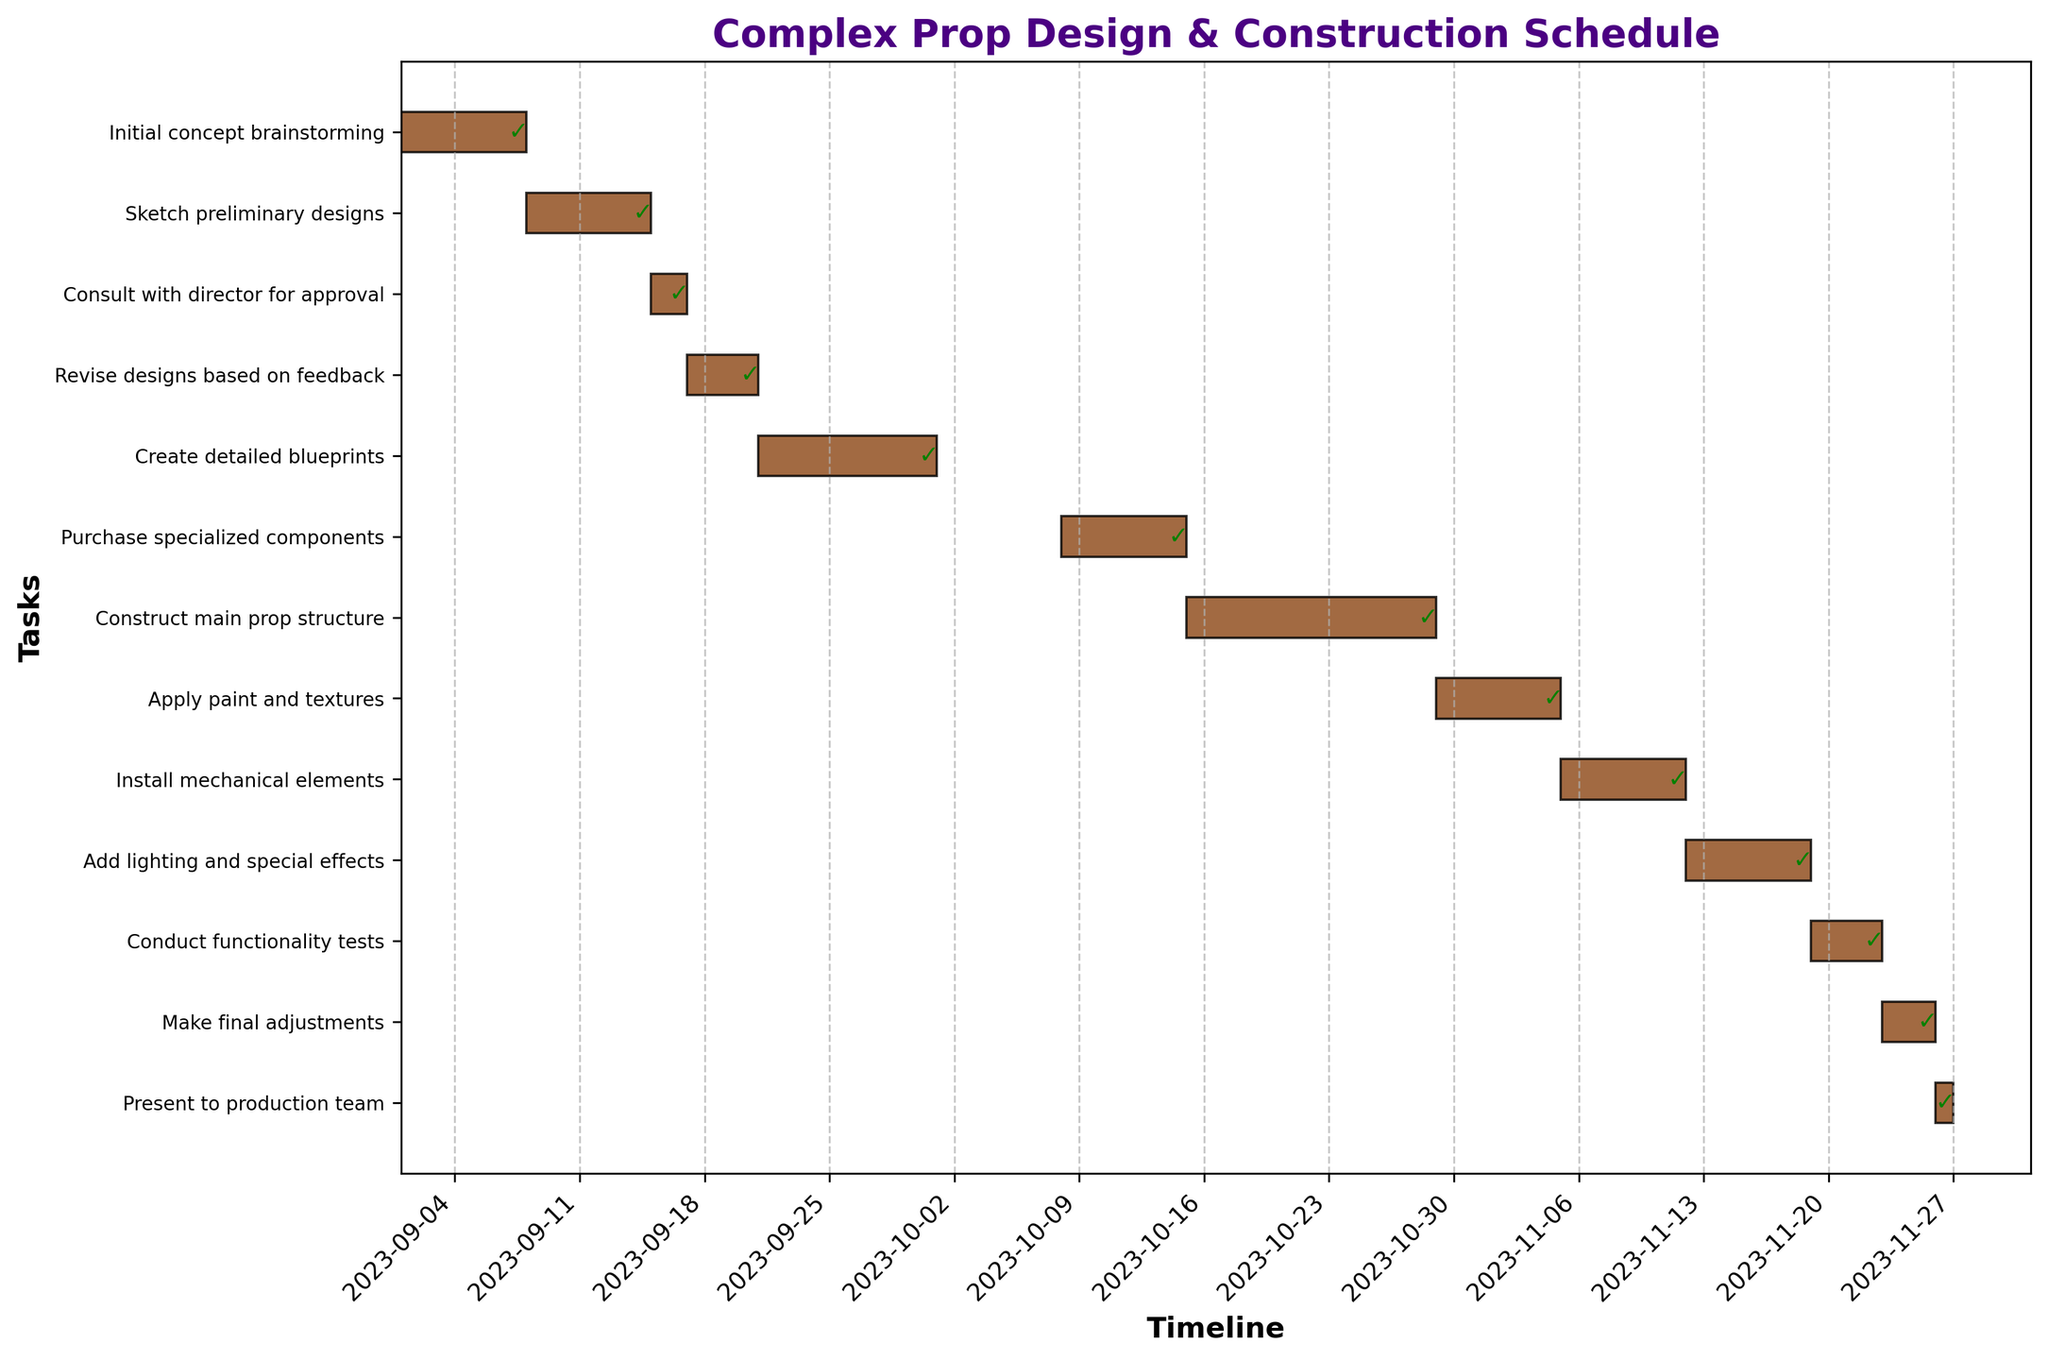What's the title of the Gantt chart? The title of the Gantt chart is located at the top-center in bold and larger font size, which typically gives an overview of the graph. In this case, it should summarize the project schedule.
Answer: Complex Prop Design & Construction Schedule How long is the duration for "Construct main prop structure" task? To find the duration, you need to look at the start and end dates for the task "Construct main prop structure" which runs from 2023-10-15 to 2023-10-28. The duration is 14 days.
Answer: 14 days Which task took the shortest time to complete? Look for the task with the shortest bar on the horizontal axis. The task "Present to production team" is completed in a single day, making it the shortest.
Answer: Present to production team What tasks are scheduled to occur in November? Identify the bars that fall within the boundaries of November in the timeline. The tasks are "Install mechanical elements," "Add lighting and special effects," "Conduct functionality tests," "Make final adjustments," and "Present to production team."
Answer: Install mechanical elements, Add lighting and special effects, Conduct functionality tests, Make final adjustments, Present to production team How many tasks have a duration of fewer than 5 days? Inspect each bar's length to determine those representing durations less than 5 days. The tasks fitting this criterion are "Consult with director for approval," "Revise designs based on feedback," "Conduct functionality tests," "Make final adjustments," and "Present to production team," totaling 5 tasks.
Answer: 5 tasks Which task immediately follows "Purchase specialized components"? Identify the bar that comes immediately after the "Purchase specialized components" bar, which ends on 2023-10-14. The next task, starting on 2023-10-15, is "Construct main prop structure."
Answer: Construct main prop structure Are there any tasks that overlap in time? To check for overlapping tasks, look for bars that overlap on the timeline. For this chart, "Purchase specialized components" overlaps with "Create detailed blueprints," and "Add lighting and special effects" overlaps with "Install mechanical elements."
Answer: Yes What is the total time span of the entire project? To find the total time span, look at the start date of the first task "Initial concept brainstorming" (2023-09-01) and the end date of the last task "Present to production team" (2023-11-26). This gives a total span of 86 days.
Answer: 86 days Which phase in the project takes the longest time? Compare the lengths of the bars. The phases are conceptualization, material sourcing, and construction. The construction phase includes tasks from "Construct main prop structure" to "Present to production team," which take the longest duration altogether.
Answer: Construction phase 